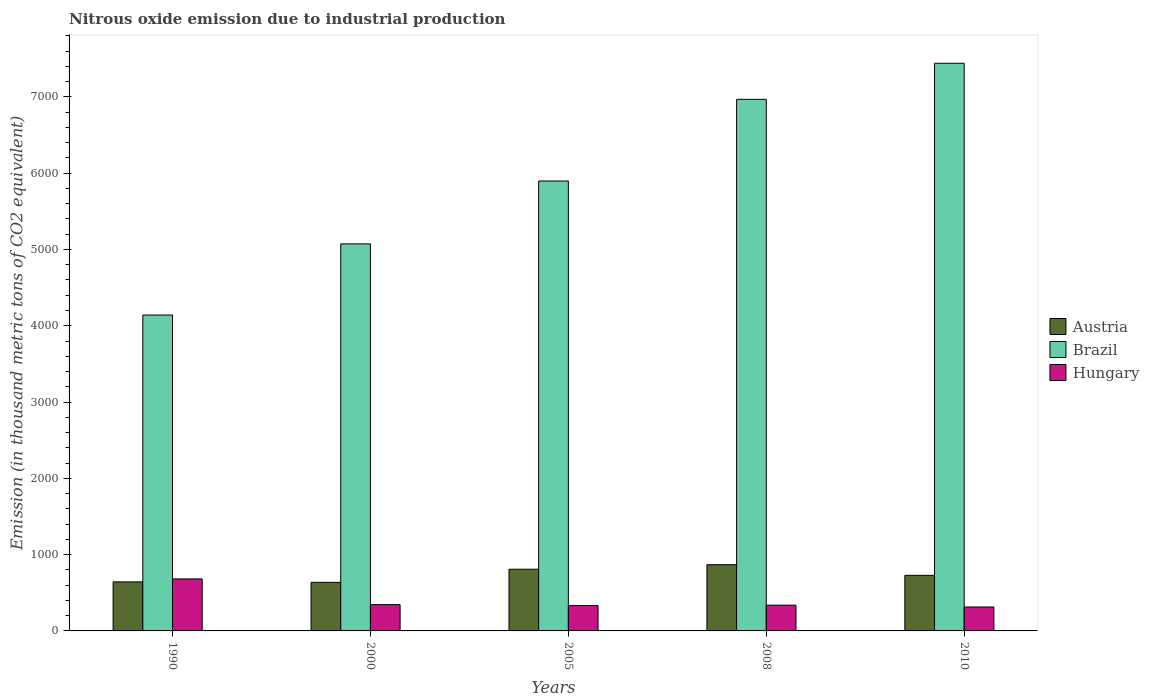How many different coloured bars are there?
Keep it short and to the point. 3. Are the number of bars per tick equal to the number of legend labels?
Your answer should be very brief. Yes. What is the amount of nitrous oxide emitted in Hungary in 2005?
Provide a short and direct response. 332.6. Across all years, what is the maximum amount of nitrous oxide emitted in Austria?
Offer a terse response. 867.9. Across all years, what is the minimum amount of nitrous oxide emitted in Brazil?
Your response must be concise. 4140.8. What is the total amount of nitrous oxide emitted in Brazil in the graph?
Provide a short and direct response. 2.95e+04. What is the difference between the amount of nitrous oxide emitted in Austria in 2000 and that in 2005?
Make the answer very short. -171.5. What is the difference between the amount of nitrous oxide emitted in Brazil in 2000 and the amount of nitrous oxide emitted in Hungary in 2005?
Provide a short and direct response. 4740.8. What is the average amount of nitrous oxide emitted in Brazil per year?
Give a very brief answer. 5904.02. In the year 1990, what is the difference between the amount of nitrous oxide emitted in Hungary and amount of nitrous oxide emitted in Austria?
Give a very brief answer. 38.8. What is the ratio of the amount of nitrous oxide emitted in Brazil in 2005 to that in 2008?
Your answer should be compact. 0.85. Is the amount of nitrous oxide emitted in Brazil in 1990 less than that in 2005?
Keep it short and to the point. Yes. What is the difference between the highest and the second highest amount of nitrous oxide emitted in Hungary?
Your answer should be very brief. 337.2. What is the difference between the highest and the lowest amount of nitrous oxide emitted in Brazil?
Your response must be concise. 3299.9. In how many years, is the amount of nitrous oxide emitted in Brazil greater than the average amount of nitrous oxide emitted in Brazil taken over all years?
Keep it short and to the point. 2. What does the 2nd bar from the right in 1990 represents?
Give a very brief answer. Brazil. Is it the case that in every year, the sum of the amount of nitrous oxide emitted in Hungary and amount of nitrous oxide emitted in Brazil is greater than the amount of nitrous oxide emitted in Austria?
Offer a terse response. Yes. How many bars are there?
Your response must be concise. 15. Are all the bars in the graph horizontal?
Make the answer very short. No. How many years are there in the graph?
Ensure brevity in your answer.  5. Are the values on the major ticks of Y-axis written in scientific E-notation?
Offer a very short reply. No. Does the graph contain any zero values?
Ensure brevity in your answer.  No. How many legend labels are there?
Your answer should be very brief. 3. What is the title of the graph?
Your answer should be very brief. Nitrous oxide emission due to industrial production. What is the label or title of the Y-axis?
Your answer should be compact. Emission (in thousand metric tons of CO2 equivalent). What is the Emission (in thousand metric tons of CO2 equivalent) of Austria in 1990?
Give a very brief answer. 642.9. What is the Emission (in thousand metric tons of CO2 equivalent) of Brazil in 1990?
Give a very brief answer. 4140.8. What is the Emission (in thousand metric tons of CO2 equivalent) of Hungary in 1990?
Your response must be concise. 681.7. What is the Emission (in thousand metric tons of CO2 equivalent) of Austria in 2000?
Provide a short and direct response. 637.1. What is the Emission (in thousand metric tons of CO2 equivalent) in Brazil in 2000?
Give a very brief answer. 5073.4. What is the Emission (in thousand metric tons of CO2 equivalent) in Hungary in 2000?
Provide a succinct answer. 344.5. What is the Emission (in thousand metric tons of CO2 equivalent) of Austria in 2005?
Offer a terse response. 808.6. What is the Emission (in thousand metric tons of CO2 equivalent) in Brazil in 2005?
Provide a succinct answer. 5897.3. What is the Emission (in thousand metric tons of CO2 equivalent) in Hungary in 2005?
Offer a terse response. 332.6. What is the Emission (in thousand metric tons of CO2 equivalent) in Austria in 2008?
Provide a short and direct response. 867.9. What is the Emission (in thousand metric tons of CO2 equivalent) of Brazil in 2008?
Your answer should be very brief. 6967.9. What is the Emission (in thousand metric tons of CO2 equivalent) of Hungary in 2008?
Your response must be concise. 337.9. What is the Emission (in thousand metric tons of CO2 equivalent) of Austria in 2010?
Keep it short and to the point. 728.3. What is the Emission (in thousand metric tons of CO2 equivalent) in Brazil in 2010?
Offer a very short reply. 7440.7. What is the Emission (in thousand metric tons of CO2 equivalent) in Hungary in 2010?
Make the answer very short. 313.6. Across all years, what is the maximum Emission (in thousand metric tons of CO2 equivalent) in Austria?
Keep it short and to the point. 867.9. Across all years, what is the maximum Emission (in thousand metric tons of CO2 equivalent) in Brazil?
Offer a very short reply. 7440.7. Across all years, what is the maximum Emission (in thousand metric tons of CO2 equivalent) of Hungary?
Offer a very short reply. 681.7. Across all years, what is the minimum Emission (in thousand metric tons of CO2 equivalent) in Austria?
Provide a short and direct response. 637.1. Across all years, what is the minimum Emission (in thousand metric tons of CO2 equivalent) of Brazil?
Keep it short and to the point. 4140.8. Across all years, what is the minimum Emission (in thousand metric tons of CO2 equivalent) in Hungary?
Offer a terse response. 313.6. What is the total Emission (in thousand metric tons of CO2 equivalent) in Austria in the graph?
Give a very brief answer. 3684.8. What is the total Emission (in thousand metric tons of CO2 equivalent) in Brazil in the graph?
Ensure brevity in your answer.  2.95e+04. What is the total Emission (in thousand metric tons of CO2 equivalent) in Hungary in the graph?
Offer a terse response. 2010.3. What is the difference between the Emission (in thousand metric tons of CO2 equivalent) of Austria in 1990 and that in 2000?
Offer a very short reply. 5.8. What is the difference between the Emission (in thousand metric tons of CO2 equivalent) of Brazil in 1990 and that in 2000?
Offer a very short reply. -932.6. What is the difference between the Emission (in thousand metric tons of CO2 equivalent) in Hungary in 1990 and that in 2000?
Provide a short and direct response. 337.2. What is the difference between the Emission (in thousand metric tons of CO2 equivalent) of Austria in 1990 and that in 2005?
Your response must be concise. -165.7. What is the difference between the Emission (in thousand metric tons of CO2 equivalent) in Brazil in 1990 and that in 2005?
Your answer should be very brief. -1756.5. What is the difference between the Emission (in thousand metric tons of CO2 equivalent) in Hungary in 1990 and that in 2005?
Provide a short and direct response. 349.1. What is the difference between the Emission (in thousand metric tons of CO2 equivalent) of Austria in 1990 and that in 2008?
Your response must be concise. -225. What is the difference between the Emission (in thousand metric tons of CO2 equivalent) of Brazil in 1990 and that in 2008?
Keep it short and to the point. -2827.1. What is the difference between the Emission (in thousand metric tons of CO2 equivalent) in Hungary in 1990 and that in 2008?
Your answer should be compact. 343.8. What is the difference between the Emission (in thousand metric tons of CO2 equivalent) in Austria in 1990 and that in 2010?
Provide a short and direct response. -85.4. What is the difference between the Emission (in thousand metric tons of CO2 equivalent) in Brazil in 1990 and that in 2010?
Your answer should be compact. -3299.9. What is the difference between the Emission (in thousand metric tons of CO2 equivalent) in Hungary in 1990 and that in 2010?
Your answer should be very brief. 368.1. What is the difference between the Emission (in thousand metric tons of CO2 equivalent) of Austria in 2000 and that in 2005?
Provide a succinct answer. -171.5. What is the difference between the Emission (in thousand metric tons of CO2 equivalent) in Brazil in 2000 and that in 2005?
Offer a very short reply. -823.9. What is the difference between the Emission (in thousand metric tons of CO2 equivalent) in Austria in 2000 and that in 2008?
Offer a terse response. -230.8. What is the difference between the Emission (in thousand metric tons of CO2 equivalent) in Brazil in 2000 and that in 2008?
Ensure brevity in your answer.  -1894.5. What is the difference between the Emission (in thousand metric tons of CO2 equivalent) of Hungary in 2000 and that in 2008?
Keep it short and to the point. 6.6. What is the difference between the Emission (in thousand metric tons of CO2 equivalent) of Austria in 2000 and that in 2010?
Provide a short and direct response. -91.2. What is the difference between the Emission (in thousand metric tons of CO2 equivalent) in Brazil in 2000 and that in 2010?
Provide a succinct answer. -2367.3. What is the difference between the Emission (in thousand metric tons of CO2 equivalent) in Hungary in 2000 and that in 2010?
Keep it short and to the point. 30.9. What is the difference between the Emission (in thousand metric tons of CO2 equivalent) in Austria in 2005 and that in 2008?
Give a very brief answer. -59.3. What is the difference between the Emission (in thousand metric tons of CO2 equivalent) of Brazil in 2005 and that in 2008?
Provide a succinct answer. -1070.6. What is the difference between the Emission (in thousand metric tons of CO2 equivalent) of Hungary in 2005 and that in 2008?
Make the answer very short. -5.3. What is the difference between the Emission (in thousand metric tons of CO2 equivalent) of Austria in 2005 and that in 2010?
Give a very brief answer. 80.3. What is the difference between the Emission (in thousand metric tons of CO2 equivalent) in Brazil in 2005 and that in 2010?
Your answer should be very brief. -1543.4. What is the difference between the Emission (in thousand metric tons of CO2 equivalent) of Austria in 2008 and that in 2010?
Your answer should be very brief. 139.6. What is the difference between the Emission (in thousand metric tons of CO2 equivalent) in Brazil in 2008 and that in 2010?
Ensure brevity in your answer.  -472.8. What is the difference between the Emission (in thousand metric tons of CO2 equivalent) of Hungary in 2008 and that in 2010?
Provide a succinct answer. 24.3. What is the difference between the Emission (in thousand metric tons of CO2 equivalent) in Austria in 1990 and the Emission (in thousand metric tons of CO2 equivalent) in Brazil in 2000?
Your response must be concise. -4430.5. What is the difference between the Emission (in thousand metric tons of CO2 equivalent) of Austria in 1990 and the Emission (in thousand metric tons of CO2 equivalent) of Hungary in 2000?
Offer a terse response. 298.4. What is the difference between the Emission (in thousand metric tons of CO2 equivalent) in Brazil in 1990 and the Emission (in thousand metric tons of CO2 equivalent) in Hungary in 2000?
Your answer should be very brief. 3796.3. What is the difference between the Emission (in thousand metric tons of CO2 equivalent) of Austria in 1990 and the Emission (in thousand metric tons of CO2 equivalent) of Brazil in 2005?
Make the answer very short. -5254.4. What is the difference between the Emission (in thousand metric tons of CO2 equivalent) in Austria in 1990 and the Emission (in thousand metric tons of CO2 equivalent) in Hungary in 2005?
Your answer should be very brief. 310.3. What is the difference between the Emission (in thousand metric tons of CO2 equivalent) of Brazil in 1990 and the Emission (in thousand metric tons of CO2 equivalent) of Hungary in 2005?
Give a very brief answer. 3808.2. What is the difference between the Emission (in thousand metric tons of CO2 equivalent) of Austria in 1990 and the Emission (in thousand metric tons of CO2 equivalent) of Brazil in 2008?
Your answer should be very brief. -6325. What is the difference between the Emission (in thousand metric tons of CO2 equivalent) of Austria in 1990 and the Emission (in thousand metric tons of CO2 equivalent) of Hungary in 2008?
Offer a terse response. 305. What is the difference between the Emission (in thousand metric tons of CO2 equivalent) of Brazil in 1990 and the Emission (in thousand metric tons of CO2 equivalent) of Hungary in 2008?
Your answer should be very brief. 3802.9. What is the difference between the Emission (in thousand metric tons of CO2 equivalent) in Austria in 1990 and the Emission (in thousand metric tons of CO2 equivalent) in Brazil in 2010?
Offer a very short reply. -6797.8. What is the difference between the Emission (in thousand metric tons of CO2 equivalent) in Austria in 1990 and the Emission (in thousand metric tons of CO2 equivalent) in Hungary in 2010?
Make the answer very short. 329.3. What is the difference between the Emission (in thousand metric tons of CO2 equivalent) of Brazil in 1990 and the Emission (in thousand metric tons of CO2 equivalent) of Hungary in 2010?
Provide a succinct answer. 3827.2. What is the difference between the Emission (in thousand metric tons of CO2 equivalent) of Austria in 2000 and the Emission (in thousand metric tons of CO2 equivalent) of Brazil in 2005?
Your answer should be compact. -5260.2. What is the difference between the Emission (in thousand metric tons of CO2 equivalent) in Austria in 2000 and the Emission (in thousand metric tons of CO2 equivalent) in Hungary in 2005?
Keep it short and to the point. 304.5. What is the difference between the Emission (in thousand metric tons of CO2 equivalent) of Brazil in 2000 and the Emission (in thousand metric tons of CO2 equivalent) of Hungary in 2005?
Provide a succinct answer. 4740.8. What is the difference between the Emission (in thousand metric tons of CO2 equivalent) in Austria in 2000 and the Emission (in thousand metric tons of CO2 equivalent) in Brazil in 2008?
Provide a succinct answer. -6330.8. What is the difference between the Emission (in thousand metric tons of CO2 equivalent) of Austria in 2000 and the Emission (in thousand metric tons of CO2 equivalent) of Hungary in 2008?
Your answer should be very brief. 299.2. What is the difference between the Emission (in thousand metric tons of CO2 equivalent) of Brazil in 2000 and the Emission (in thousand metric tons of CO2 equivalent) of Hungary in 2008?
Provide a succinct answer. 4735.5. What is the difference between the Emission (in thousand metric tons of CO2 equivalent) of Austria in 2000 and the Emission (in thousand metric tons of CO2 equivalent) of Brazil in 2010?
Keep it short and to the point. -6803.6. What is the difference between the Emission (in thousand metric tons of CO2 equivalent) in Austria in 2000 and the Emission (in thousand metric tons of CO2 equivalent) in Hungary in 2010?
Keep it short and to the point. 323.5. What is the difference between the Emission (in thousand metric tons of CO2 equivalent) of Brazil in 2000 and the Emission (in thousand metric tons of CO2 equivalent) of Hungary in 2010?
Your response must be concise. 4759.8. What is the difference between the Emission (in thousand metric tons of CO2 equivalent) of Austria in 2005 and the Emission (in thousand metric tons of CO2 equivalent) of Brazil in 2008?
Offer a terse response. -6159.3. What is the difference between the Emission (in thousand metric tons of CO2 equivalent) of Austria in 2005 and the Emission (in thousand metric tons of CO2 equivalent) of Hungary in 2008?
Your answer should be very brief. 470.7. What is the difference between the Emission (in thousand metric tons of CO2 equivalent) in Brazil in 2005 and the Emission (in thousand metric tons of CO2 equivalent) in Hungary in 2008?
Your answer should be compact. 5559.4. What is the difference between the Emission (in thousand metric tons of CO2 equivalent) of Austria in 2005 and the Emission (in thousand metric tons of CO2 equivalent) of Brazil in 2010?
Your answer should be very brief. -6632.1. What is the difference between the Emission (in thousand metric tons of CO2 equivalent) of Austria in 2005 and the Emission (in thousand metric tons of CO2 equivalent) of Hungary in 2010?
Offer a terse response. 495. What is the difference between the Emission (in thousand metric tons of CO2 equivalent) in Brazil in 2005 and the Emission (in thousand metric tons of CO2 equivalent) in Hungary in 2010?
Give a very brief answer. 5583.7. What is the difference between the Emission (in thousand metric tons of CO2 equivalent) of Austria in 2008 and the Emission (in thousand metric tons of CO2 equivalent) of Brazil in 2010?
Ensure brevity in your answer.  -6572.8. What is the difference between the Emission (in thousand metric tons of CO2 equivalent) of Austria in 2008 and the Emission (in thousand metric tons of CO2 equivalent) of Hungary in 2010?
Your answer should be very brief. 554.3. What is the difference between the Emission (in thousand metric tons of CO2 equivalent) in Brazil in 2008 and the Emission (in thousand metric tons of CO2 equivalent) in Hungary in 2010?
Provide a short and direct response. 6654.3. What is the average Emission (in thousand metric tons of CO2 equivalent) in Austria per year?
Your answer should be compact. 736.96. What is the average Emission (in thousand metric tons of CO2 equivalent) of Brazil per year?
Your response must be concise. 5904.02. What is the average Emission (in thousand metric tons of CO2 equivalent) of Hungary per year?
Your answer should be very brief. 402.06. In the year 1990, what is the difference between the Emission (in thousand metric tons of CO2 equivalent) in Austria and Emission (in thousand metric tons of CO2 equivalent) in Brazil?
Your answer should be compact. -3497.9. In the year 1990, what is the difference between the Emission (in thousand metric tons of CO2 equivalent) of Austria and Emission (in thousand metric tons of CO2 equivalent) of Hungary?
Provide a succinct answer. -38.8. In the year 1990, what is the difference between the Emission (in thousand metric tons of CO2 equivalent) in Brazil and Emission (in thousand metric tons of CO2 equivalent) in Hungary?
Give a very brief answer. 3459.1. In the year 2000, what is the difference between the Emission (in thousand metric tons of CO2 equivalent) in Austria and Emission (in thousand metric tons of CO2 equivalent) in Brazil?
Your answer should be compact. -4436.3. In the year 2000, what is the difference between the Emission (in thousand metric tons of CO2 equivalent) in Austria and Emission (in thousand metric tons of CO2 equivalent) in Hungary?
Provide a short and direct response. 292.6. In the year 2000, what is the difference between the Emission (in thousand metric tons of CO2 equivalent) in Brazil and Emission (in thousand metric tons of CO2 equivalent) in Hungary?
Make the answer very short. 4728.9. In the year 2005, what is the difference between the Emission (in thousand metric tons of CO2 equivalent) in Austria and Emission (in thousand metric tons of CO2 equivalent) in Brazil?
Give a very brief answer. -5088.7. In the year 2005, what is the difference between the Emission (in thousand metric tons of CO2 equivalent) of Austria and Emission (in thousand metric tons of CO2 equivalent) of Hungary?
Provide a short and direct response. 476. In the year 2005, what is the difference between the Emission (in thousand metric tons of CO2 equivalent) of Brazil and Emission (in thousand metric tons of CO2 equivalent) of Hungary?
Your answer should be very brief. 5564.7. In the year 2008, what is the difference between the Emission (in thousand metric tons of CO2 equivalent) of Austria and Emission (in thousand metric tons of CO2 equivalent) of Brazil?
Provide a short and direct response. -6100. In the year 2008, what is the difference between the Emission (in thousand metric tons of CO2 equivalent) in Austria and Emission (in thousand metric tons of CO2 equivalent) in Hungary?
Give a very brief answer. 530. In the year 2008, what is the difference between the Emission (in thousand metric tons of CO2 equivalent) of Brazil and Emission (in thousand metric tons of CO2 equivalent) of Hungary?
Keep it short and to the point. 6630. In the year 2010, what is the difference between the Emission (in thousand metric tons of CO2 equivalent) of Austria and Emission (in thousand metric tons of CO2 equivalent) of Brazil?
Offer a terse response. -6712.4. In the year 2010, what is the difference between the Emission (in thousand metric tons of CO2 equivalent) in Austria and Emission (in thousand metric tons of CO2 equivalent) in Hungary?
Ensure brevity in your answer.  414.7. In the year 2010, what is the difference between the Emission (in thousand metric tons of CO2 equivalent) in Brazil and Emission (in thousand metric tons of CO2 equivalent) in Hungary?
Ensure brevity in your answer.  7127.1. What is the ratio of the Emission (in thousand metric tons of CO2 equivalent) of Austria in 1990 to that in 2000?
Your answer should be compact. 1.01. What is the ratio of the Emission (in thousand metric tons of CO2 equivalent) of Brazil in 1990 to that in 2000?
Offer a terse response. 0.82. What is the ratio of the Emission (in thousand metric tons of CO2 equivalent) of Hungary in 1990 to that in 2000?
Keep it short and to the point. 1.98. What is the ratio of the Emission (in thousand metric tons of CO2 equivalent) of Austria in 1990 to that in 2005?
Provide a succinct answer. 0.8. What is the ratio of the Emission (in thousand metric tons of CO2 equivalent) of Brazil in 1990 to that in 2005?
Provide a short and direct response. 0.7. What is the ratio of the Emission (in thousand metric tons of CO2 equivalent) of Hungary in 1990 to that in 2005?
Offer a very short reply. 2.05. What is the ratio of the Emission (in thousand metric tons of CO2 equivalent) of Austria in 1990 to that in 2008?
Give a very brief answer. 0.74. What is the ratio of the Emission (in thousand metric tons of CO2 equivalent) in Brazil in 1990 to that in 2008?
Your answer should be very brief. 0.59. What is the ratio of the Emission (in thousand metric tons of CO2 equivalent) in Hungary in 1990 to that in 2008?
Your answer should be compact. 2.02. What is the ratio of the Emission (in thousand metric tons of CO2 equivalent) in Austria in 1990 to that in 2010?
Provide a short and direct response. 0.88. What is the ratio of the Emission (in thousand metric tons of CO2 equivalent) in Brazil in 1990 to that in 2010?
Give a very brief answer. 0.56. What is the ratio of the Emission (in thousand metric tons of CO2 equivalent) in Hungary in 1990 to that in 2010?
Ensure brevity in your answer.  2.17. What is the ratio of the Emission (in thousand metric tons of CO2 equivalent) in Austria in 2000 to that in 2005?
Keep it short and to the point. 0.79. What is the ratio of the Emission (in thousand metric tons of CO2 equivalent) in Brazil in 2000 to that in 2005?
Your response must be concise. 0.86. What is the ratio of the Emission (in thousand metric tons of CO2 equivalent) in Hungary in 2000 to that in 2005?
Offer a terse response. 1.04. What is the ratio of the Emission (in thousand metric tons of CO2 equivalent) in Austria in 2000 to that in 2008?
Ensure brevity in your answer.  0.73. What is the ratio of the Emission (in thousand metric tons of CO2 equivalent) of Brazil in 2000 to that in 2008?
Offer a terse response. 0.73. What is the ratio of the Emission (in thousand metric tons of CO2 equivalent) in Hungary in 2000 to that in 2008?
Provide a short and direct response. 1.02. What is the ratio of the Emission (in thousand metric tons of CO2 equivalent) in Austria in 2000 to that in 2010?
Give a very brief answer. 0.87. What is the ratio of the Emission (in thousand metric tons of CO2 equivalent) in Brazil in 2000 to that in 2010?
Provide a succinct answer. 0.68. What is the ratio of the Emission (in thousand metric tons of CO2 equivalent) in Hungary in 2000 to that in 2010?
Provide a short and direct response. 1.1. What is the ratio of the Emission (in thousand metric tons of CO2 equivalent) in Austria in 2005 to that in 2008?
Provide a short and direct response. 0.93. What is the ratio of the Emission (in thousand metric tons of CO2 equivalent) of Brazil in 2005 to that in 2008?
Ensure brevity in your answer.  0.85. What is the ratio of the Emission (in thousand metric tons of CO2 equivalent) of Hungary in 2005 to that in 2008?
Make the answer very short. 0.98. What is the ratio of the Emission (in thousand metric tons of CO2 equivalent) in Austria in 2005 to that in 2010?
Make the answer very short. 1.11. What is the ratio of the Emission (in thousand metric tons of CO2 equivalent) in Brazil in 2005 to that in 2010?
Offer a terse response. 0.79. What is the ratio of the Emission (in thousand metric tons of CO2 equivalent) of Hungary in 2005 to that in 2010?
Make the answer very short. 1.06. What is the ratio of the Emission (in thousand metric tons of CO2 equivalent) in Austria in 2008 to that in 2010?
Provide a succinct answer. 1.19. What is the ratio of the Emission (in thousand metric tons of CO2 equivalent) in Brazil in 2008 to that in 2010?
Offer a very short reply. 0.94. What is the ratio of the Emission (in thousand metric tons of CO2 equivalent) of Hungary in 2008 to that in 2010?
Give a very brief answer. 1.08. What is the difference between the highest and the second highest Emission (in thousand metric tons of CO2 equivalent) in Austria?
Ensure brevity in your answer.  59.3. What is the difference between the highest and the second highest Emission (in thousand metric tons of CO2 equivalent) in Brazil?
Ensure brevity in your answer.  472.8. What is the difference between the highest and the second highest Emission (in thousand metric tons of CO2 equivalent) of Hungary?
Give a very brief answer. 337.2. What is the difference between the highest and the lowest Emission (in thousand metric tons of CO2 equivalent) of Austria?
Offer a terse response. 230.8. What is the difference between the highest and the lowest Emission (in thousand metric tons of CO2 equivalent) of Brazil?
Your answer should be very brief. 3299.9. What is the difference between the highest and the lowest Emission (in thousand metric tons of CO2 equivalent) in Hungary?
Keep it short and to the point. 368.1. 